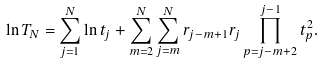Convert formula to latex. <formula><loc_0><loc_0><loc_500><loc_500>\ln T _ { N } = \sum _ { j = 1 } ^ { N } \ln t _ { j } + \sum _ { m = 2 } ^ { N } \sum _ { j = m } ^ { N } r _ { j - m + 1 } r _ { j } \prod _ { p = j - m + 2 } ^ { j - 1 } t _ { p } ^ { 2 } .</formula> 